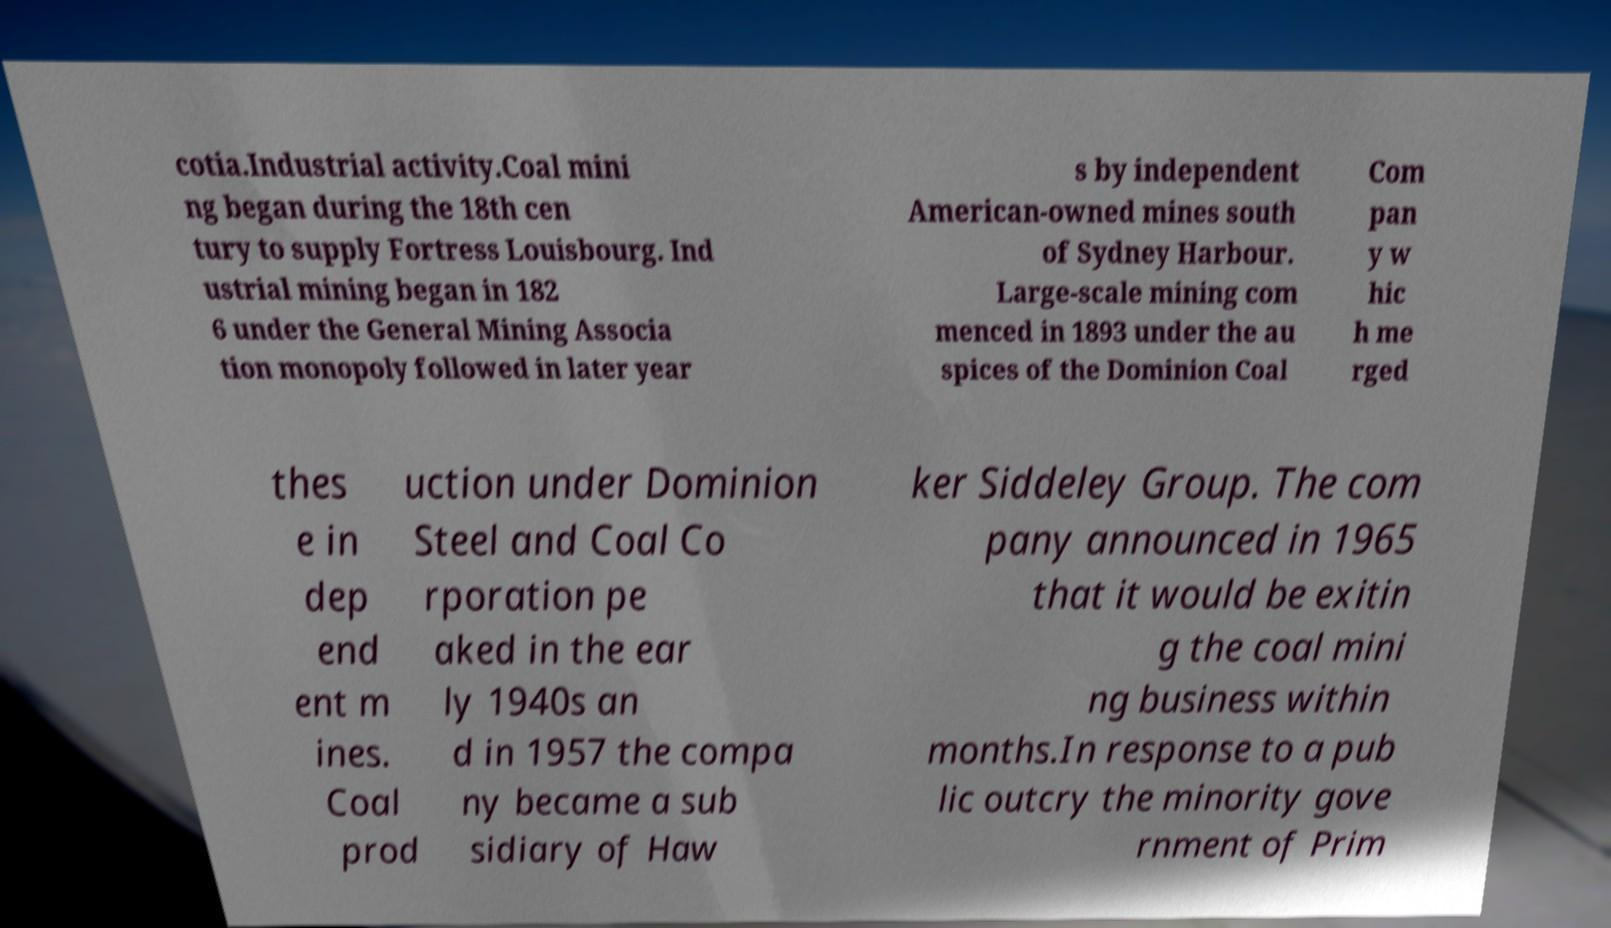Could you assist in decoding the text presented in this image and type it out clearly? cotia.Industrial activity.Coal mini ng began during the 18th cen tury to supply Fortress Louisbourg. Ind ustrial mining began in 182 6 under the General Mining Associa tion monopoly followed in later year s by independent American-owned mines south of Sydney Harbour. Large-scale mining com menced in 1893 under the au spices of the Dominion Coal Com pan y w hic h me rged thes e in dep end ent m ines. Coal prod uction under Dominion Steel and Coal Co rporation pe aked in the ear ly 1940s an d in 1957 the compa ny became a sub sidiary of Haw ker Siddeley Group. The com pany announced in 1965 that it would be exitin g the coal mini ng business within months.In response to a pub lic outcry the minority gove rnment of Prim 